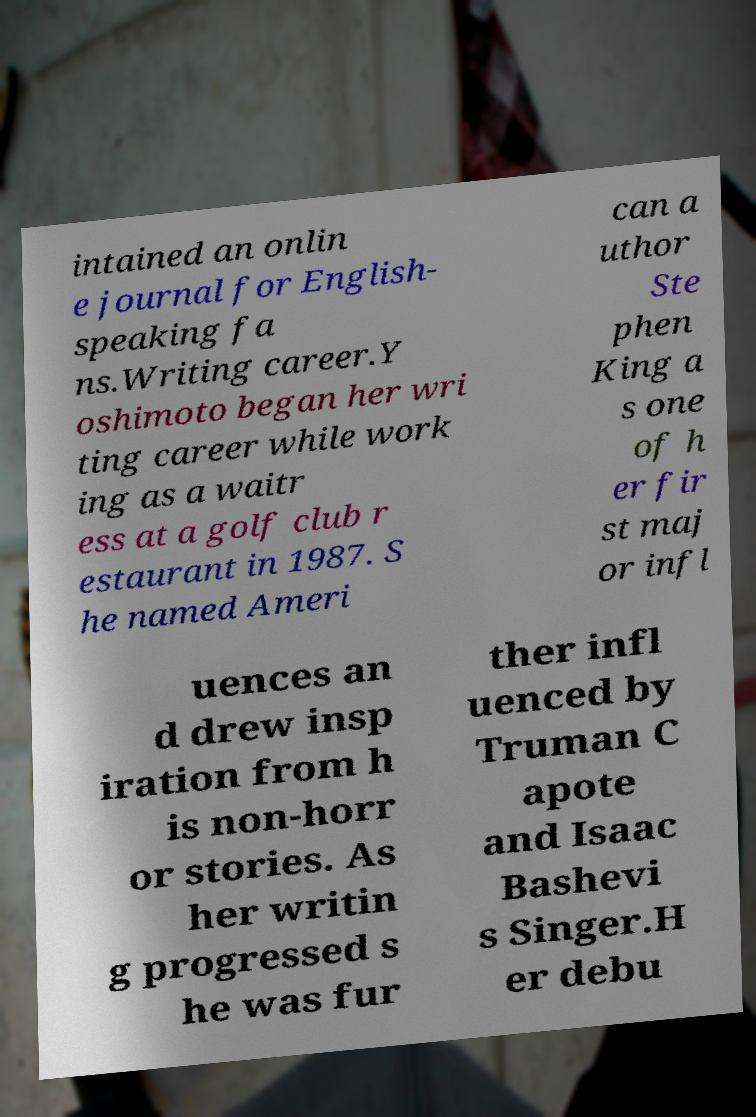For documentation purposes, I need the text within this image transcribed. Could you provide that? intained an onlin e journal for English- speaking fa ns.Writing career.Y oshimoto began her wri ting career while work ing as a waitr ess at a golf club r estaurant in 1987. S he named Ameri can a uthor Ste phen King a s one of h er fir st maj or infl uences an d drew insp iration from h is non-horr or stories. As her writin g progressed s he was fur ther infl uenced by Truman C apote and Isaac Bashevi s Singer.H er debu 